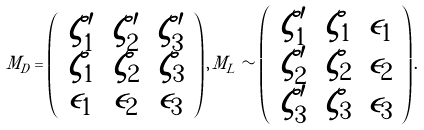Convert formula to latex. <formula><loc_0><loc_0><loc_500><loc_500>M _ { D } = \left ( \begin{array} { c c c } \zeta ^ { \prime } _ { 1 } & \zeta ^ { \prime } _ { 2 } & \zeta ^ { \prime } _ { 3 } \\ \zeta _ { 1 } & \zeta _ { 2 } & \zeta _ { 3 } \\ \epsilon _ { 1 } & \epsilon _ { 2 } & \epsilon _ { 3 } \end{array} \right ) , \, M _ { L } \sim \left ( \begin{array} { c c c } \zeta ^ { \prime } _ { 1 } & \zeta _ { 1 } & \epsilon _ { 1 } \\ \zeta ^ { \prime } _ { 2 } & \zeta _ { 2 } & \epsilon _ { 2 } \\ \zeta ^ { \prime } _ { 3 } & \zeta _ { 3 } & \epsilon _ { 3 } \end{array} \right ) .</formula> 